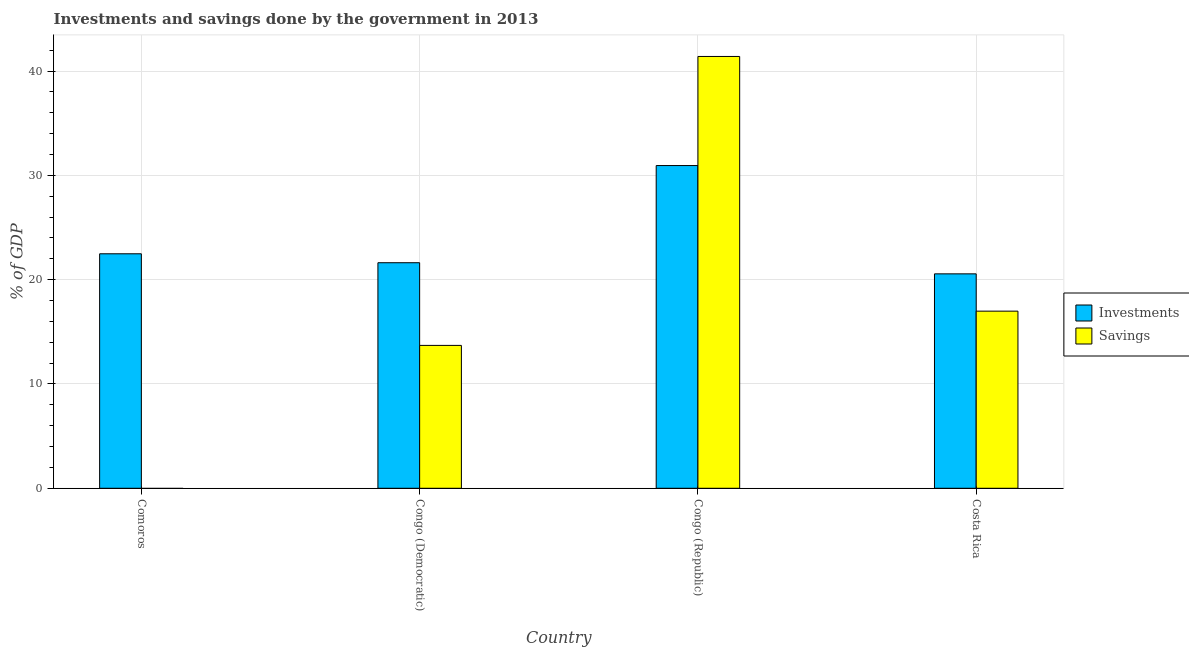Are the number of bars per tick equal to the number of legend labels?
Provide a succinct answer. No. Are the number of bars on each tick of the X-axis equal?
Provide a short and direct response. No. How many bars are there on the 3rd tick from the left?
Provide a short and direct response. 2. What is the label of the 2nd group of bars from the left?
Your answer should be very brief. Congo (Democratic). In how many cases, is the number of bars for a given country not equal to the number of legend labels?
Provide a succinct answer. 1. What is the investments of government in Congo (Democratic)?
Ensure brevity in your answer.  21.63. Across all countries, what is the maximum investments of government?
Your answer should be very brief. 30.94. Across all countries, what is the minimum investments of government?
Your answer should be compact. 20.56. In which country was the investments of government maximum?
Give a very brief answer. Congo (Republic). What is the total investments of government in the graph?
Provide a succinct answer. 95.62. What is the difference between the investments of government in Comoros and that in Costa Rica?
Provide a succinct answer. 1.92. What is the difference between the savings of government in Congo (Republic) and the investments of government in Congo (Democratic)?
Provide a short and direct response. 19.78. What is the average investments of government per country?
Ensure brevity in your answer.  23.9. What is the difference between the investments of government and savings of government in Costa Rica?
Give a very brief answer. 3.58. In how many countries, is the investments of government greater than 22 %?
Your answer should be very brief. 2. What is the ratio of the savings of government in Congo (Democratic) to that in Congo (Republic)?
Your answer should be compact. 0.33. Is the savings of government in Congo (Democratic) less than that in Costa Rica?
Provide a succinct answer. Yes. What is the difference between the highest and the second highest savings of government?
Offer a very short reply. 24.42. What is the difference between the highest and the lowest investments of government?
Keep it short and to the point. 10.38. Are all the bars in the graph horizontal?
Make the answer very short. No. What is the difference between two consecutive major ticks on the Y-axis?
Keep it short and to the point. 10. Does the graph contain any zero values?
Make the answer very short. Yes. Where does the legend appear in the graph?
Ensure brevity in your answer.  Center right. How are the legend labels stacked?
Make the answer very short. Vertical. What is the title of the graph?
Make the answer very short. Investments and savings done by the government in 2013. Does "Age 65(male)" appear as one of the legend labels in the graph?
Give a very brief answer. No. What is the label or title of the X-axis?
Provide a short and direct response. Country. What is the label or title of the Y-axis?
Keep it short and to the point. % of GDP. What is the % of GDP of Investments in Comoros?
Keep it short and to the point. 22.48. What is the % of GDP of Savings in Comoros?
Your answer should be very brief. 0. What is the % of GDP in Investments in Congo (Democratic)?
Offer a terse response. 21.63. What is the % of GDP of Savings in Congo (Democratic)?
Provide a short and direct response. 13.7. What is the % of GDP of Investments in Congo (Republic)?
Your answer should be compact. 30.94. What is the % of GDP of Savings in Congo (Republic)?
Your response must be concise. 41.4. What is the % of GDP in Investments in Costa Rica?
Your response must be concise. 20.56. What is the % of GDP of Savings in Costa Rica?
Keep it short and to the point. 16.99. Across all countries, what is the maximum % of GDP of Investments?
Offer a very short reply. 30.94. Across all countries, what is the maximum % of GDP in Savings?
Offer a very short reply. 41.4. Across all countries, what is the minimum % of GDP of Investments?
Give a very brief answer. 20.56. What is the total % of GDP in Investments in the graph?
Ensure brevity in your answer.  95.62. What is the total % of GDP in Savings in the graph?
Offer a terse response. 72.09. What is the difference between the % of GDP in Investments in Comoros and that in Congo (Democratic)?
Ensure brevity in your answer.  0.86. What is the difference between the % of GDP in Investments in Comoros and that in Congo (Republic)?
Make the answer very short. -8.46. What is the difference between the % of GDP of Investments in Comoros and that in Costa Rica?
Your response must be concise. 1.92. What is the difference between the % of GDP of Investments in Congo (Democratic) and that in Congo (Republic)?
Ensure brevity in your answer.  -9.32. What is the difference between the % of GDP of Savings in Congo (Democratic) and that in Congo (Republic)?
Provide a short and direct response. -27.71. What is the difference between the % of GDP in Investments in Congo (Democratic) and that in Costa Rica?
Keep it short and to the point. 1.07. What is the difference between the % of GDP in Savings in Congo (Democratic) and that in Costa Rica?
Ensure brevity in your answer.  -3.29. What is the difference between the % of GDP in Investments in Congo (Republic) and that in Costa Rica?
Ensure brevity in your answer.  10.38. What is the difference between the % of GDP of Savings in Congo (Republic) and that in Costa Rica?
Your answer should be compact. 24.42. What is the difference between the % of GDP of Investments in Comoros and the % of GDP of Savings in Congo (Democratic)?
Make the answer very short. 8.79. What is the difference between the % of GDP of Investments in Comoros and the % of GDP of Savings in Congo (Republic)?
Make the answer very short. -18.92. What is the difference between the % of GDP of Investments in Comoros and the % of GDP of Savings in Costa Rica?
Offer a terse response. 5.5. What is the difference between the % of GDP of Investments in Congo (Democratic) and the % of GDP of Savings in Congo (Republic)?
Your response must be concise. -19.78. What is the difference between the % of GDP in Investments in Congo (Democratic) and the % of GDP in Savings in Costa Rica?
Your response must be concise. 4.64. What is the difference between the % of GDP in Investments in Congo (Republic) and the % of GDP in Savings in Costa Rica?
Keep it short and to the point. 13.96. What is the average % of GDP in Investments per country?
Offer a very short reply. 23.9. What is the average % of GDP in Savings per country?
Offer a terse response. 18.02. What is the difference between the % of GDP of Investments and % of GDP of Savings in Congo (Democratic)?
Offer a terse response. 7.93. What is the difference between the % of GDP in Investments and % of GDP in Savings in Congo (Republic)?
Provide a succinct answer. -10.46. What is the difference between the % of GDP in Investments and % of GDP in Savings in Costa Rica?
Offer a very short reply. 3.58. What is the ratio of the % of GDP in Investments in Comoros to that in Congo (Democratic)?
Provide a short and direct response. 1.04. What is the ratio of the % of GDP of Investments in Comoros to that in Congo (Republic)?
Give a very brief answer. 0.73. What is the ratio of the % of GDP in Investments in Comoros to that in Costa Rica?
Offer a terse response. 1.09. What is the ratio of the % of GDP in Investments in Congo (Democratic) to that in Congo (Republic)?
Ensure brevity in your answer.  0.7. What is the ratio of the % of GDP in Savings in Congo (Democratic) to that in Congo (Republic)?
Keep it short and to the point. 0.33. What is the ratio of the % of GDP of Investments in Congo (Democratic) to that in Costa Rica?
Give a very brief answer. 1.05. What is the ratio of the % of GDP in Savings in Congo (Democratic) to that in Costa Rica?
Your answer should be compact. 0.81. What is the ratio of the % of GDP in Investments in Congo (Republic) to that in Costa Rica?
Provide a short and direct response. 1.51. What is the ratio of the % of GDP in Savings in Congo (Republic) to that in Costa Rica?
Your answer should be very brief. 2.44. What is the difference between the highest and the second highest % of GDP of Investments?
Keep it short and to the point. 8.46. What is the difference between the highest and the second highest % of GDP in Savings?
Your answer should be compact. 24.42. What is the difference between the highest and the lowest % of GDP of Investments?
Keep it short and to the point. 10.38. What is the difference between the highest and the lowest % of GDP in Savings?
Your response must be concise. 41.41. 